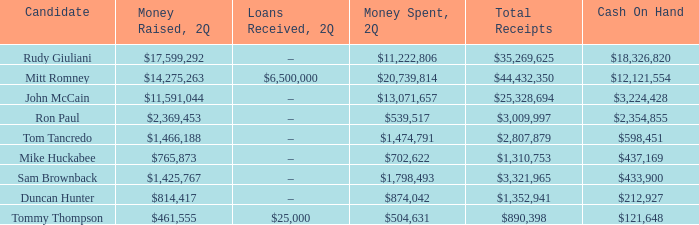Tell me the total receipts for tom tancredo $2,807,879. 